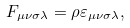<formula> <loc_0><loc_0><loc_500><loc_500>F _ { \mu \nu \sigma \lambda } = \rho \varepsilon _ { \mu \nu \sigma \lambda } ,</formula> 